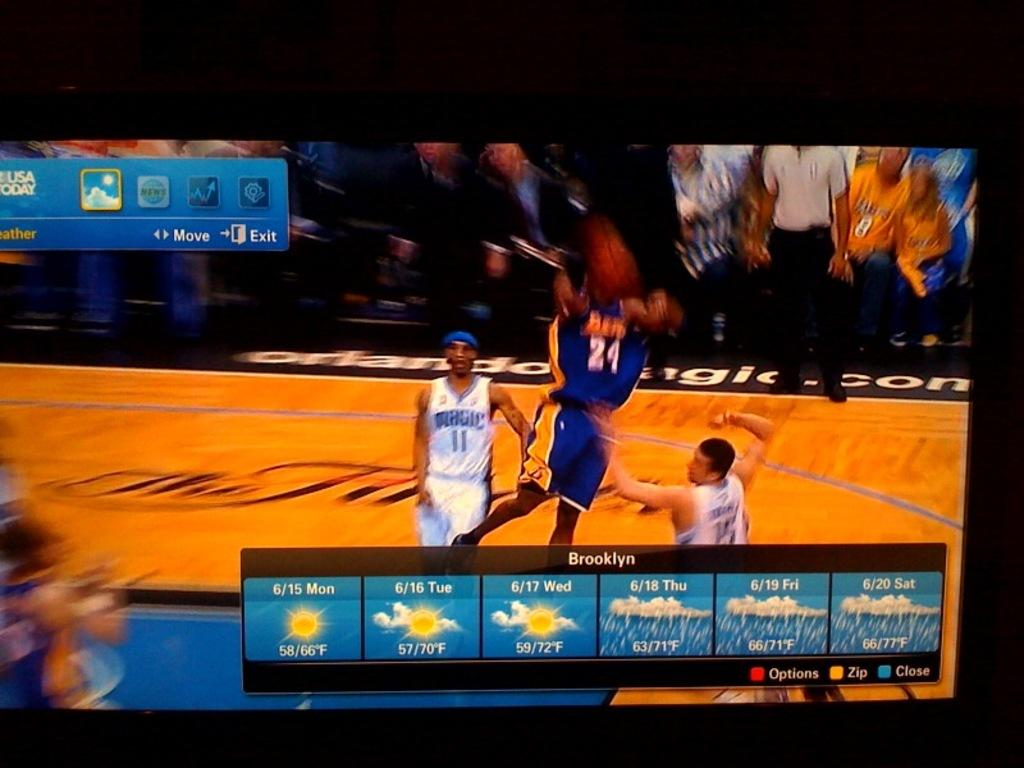<image>
Render a clear and concise summary of the photo. A weather screen for Brooklyn shows the forecast on top of a basketball game. 